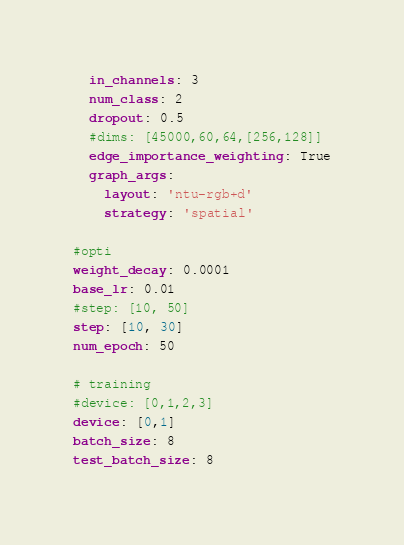<code> <loc_0><loc_0><loc_500><loc_500><_YAML_>  in_channels: 3
  num_class: 2
  dropout: 0.5
  #dims: [45000,60,64,[256,128]]
  edge_importance_weighting: True
  graph_args:
    layout: 'ntu-rgb+d'
    strategy: 'spatial'

#opti
weight_decay: 0.0001
base_lr: 0.01
#step: [10, 50]
step: [10, 30]
num_epoch: 50

# training
#device: [0,1,2,3]
device: [0,1]
batch_size: 8
test_batch_size: 8
</code> 